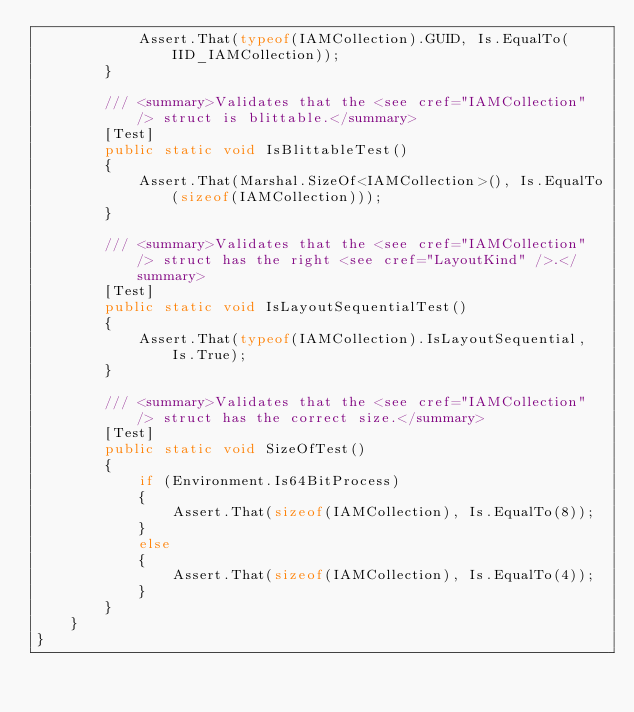<code> <loc_0><loc_0><loc_500><loc_500><_C#_>            Assert.That(typeof(IAMCollection).GUID, Is.EqualTo(IID_IAMCollection));
        }

        /// <summary>Validates that the <see cref="IAMCollection" /> struct is blittable.</summary>
        [Test]
        public static void IsBlittableTest()
        {
            Assert.That(Marshal.SizeOf<IAMCollection>(), Is.EqualTo(sizeof(IAMCollection)));
        }

        /// <summary>Validates that the <see cref="IAMCollection" /> struct has the right <see cref="LayoutKind" />.</summary>
        [Test]
        public static void IsLayoutSequentialTest()
        {
            Assert.That(typeof(IAMCollection).IsLayoutSequential, Is.True);
        }

        /// <summary>Validates that the <see cref="IAMCollection" /> struct has the correct size.</summary>
        [Test]
        public static void SizeOfTest()
        {
            if (Environment.Is64BitProcess)
            {
                Assert.That(sizeof(IAMCollection), Is.EqualTo(8));
            }
            else
            {
                Assert.That(sizeof(IAMCollection), Is.EqualTo(4));
            }
        }
    }
}
</code> 